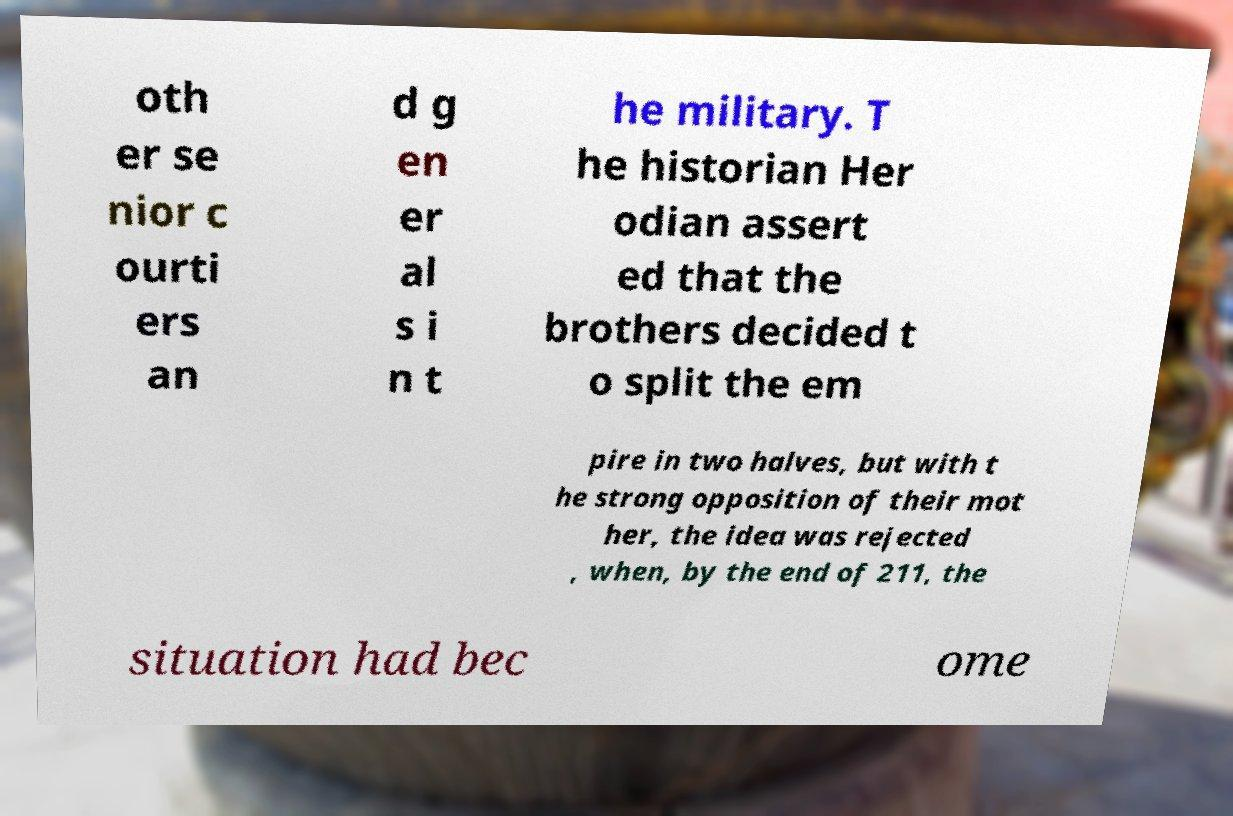Can you read and provide the text displayed in the image?This photo seems to have some interesting text. Can you extract and type it out for me? oth er se nior c ourti ers an d g en er al s i n t he military. T he historian Her odian assert ed that the brothers decided t o split the em pire in two halves, but with t he strong opposition of their mot her, the idea was rejected , when, by the end of 211, the situation had bec ome 